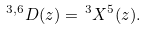Convert formula to latex. <formula><loc_0><loc_0><loc_500><loc_500>^ { 3 , 6 } D ( z ) = \, ^ { 3 } X ^ { 5 } ( z ) .</formula> 